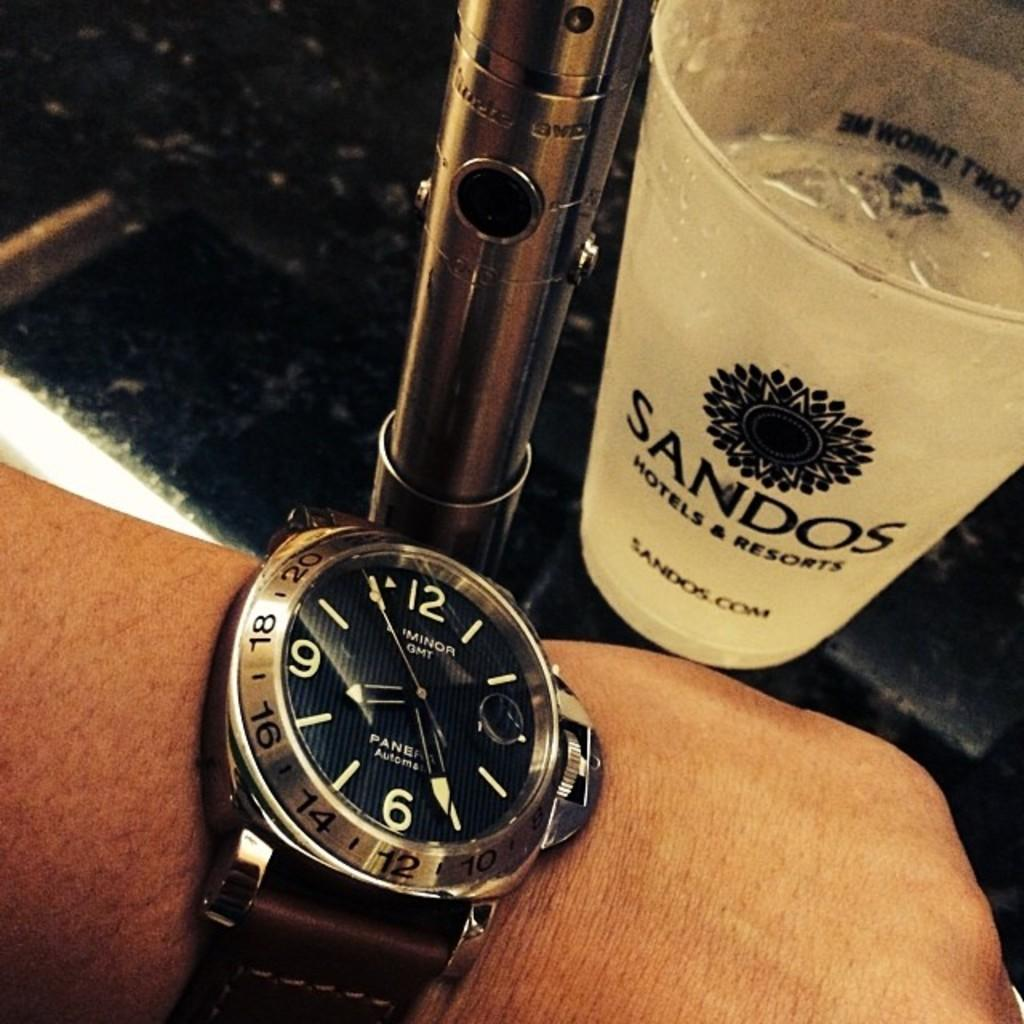<image>
Summarize the visual content of the image. A wrist watch and a cup with the Sandos name on it. 